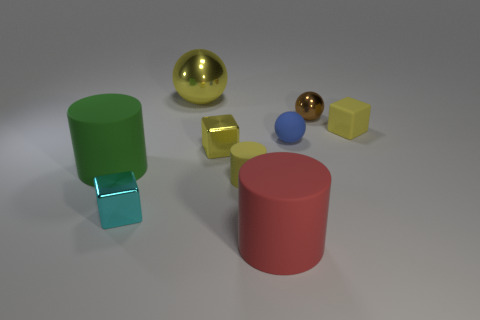There is a small shiny block behind the green thing; does it have the same color as the cube that is to the right of the red cylinder?
Your response must be concise. Yes. There is a small matte block that is behind the red cylinder; is its color the same as the small matte cylinder?
Ensure brevity in your answer.  Yes. There is a ball that is the same color as the rubber cube; what size is it?
Keep it short and to the point. Large. There is a yellow ball that is made of the same material as the brown thing; what size is it?
Ensure brevity in your answer.  Large. What number of gray objects are matte balls or tiny rubber cylinders?
Your answer should be compact. 0. The other shiny thing that is the same color as the large metal object is what shape?
Ensure brevity in your answer.  Cube. Is there anything else that is made of the same material as the tiny yellow cylinder?
Provide a short and direct response. Yes. There is a metallic thing right of the red thing; is it the same shape as the rubber thing left of the large yellow shiny ball?
Your answer should be compact. No. What number of spheres are there?
Your answer should be very brief. 3. There is a small brown thing that is made of the same material as the big yellow ball; what shape is it?
Offer a terse response. Sphere. 